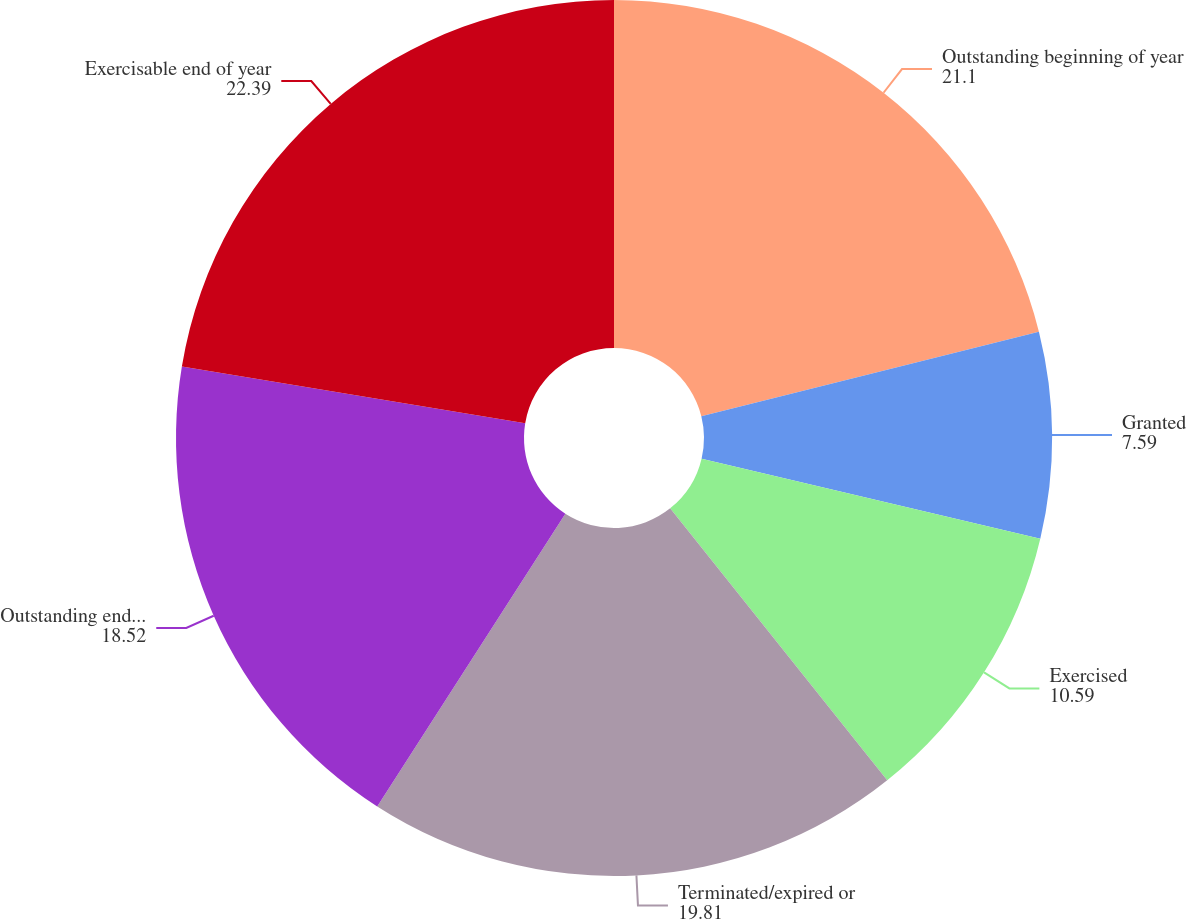Convert chart to OTSL. <chart><loc_0><loc_0><loc_500><loc_500><pie_chart><fcel>Outstanding beginning of year<fcel>Granted<fcel>Exercised<fcel>Terminated/expired or<fcel>Outstanding end of year<fcel>Exercisable end of year<nl><fcel>21.1%<fcel>7.59%<fcel>10.59%<fcel>19.81%<fcel>18.52%<fcel>22.39%<nl></chart> 